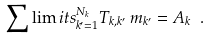<formula> <loc_0><loc_0><loc_500><loc_500>\sum \lim i t s _ { k ^ { \prime } = 1 } ^ { N _ { k } } T _ { k , k ^ { \prime } } \, m _ { k ^ { \prime } } = A _ { k } \ .</formula> 